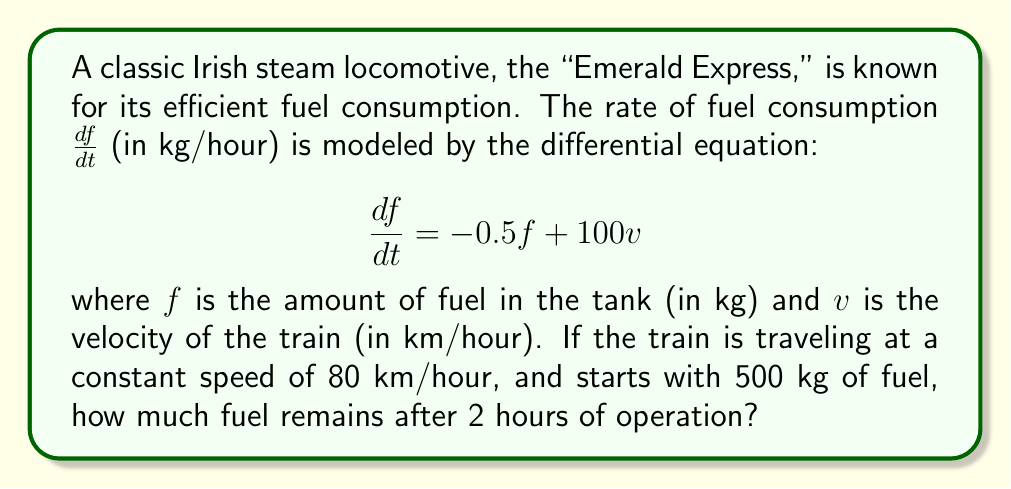Solve this math problem. To solve this problem, we need to follow these steps:

1) First, we substitute the given velocity into the differential equation:
   $$\frac{df}{dt} = -0.5f + 100(80) = -0.5f + 8000$$

2) This is a first-order linear differential equation of the form:
   $$\frac{df}{dt} + 0.5f = 8000$$

3) The general solution to this type of equation is:
   $$f(t) = Ce^{-0.5t} + 16000$$
   where $C$ is a constant we need to determine.

4) We use the initial condition: at $t=0$, $f(0) = 500$:
   $$500 = C + 16000$$
   $$C = -15500$$

5) So, our particular solution is:
   $$f(t) = -15500e^{-0.5t} + 16000$$

6) To find the fuel remaining after 2 hours, we evaluate $f(2)$:
   $$f(2) = -15500e^{-0.5(2)} + 16000$$
   $$= -15500e^{-1} + 16000$$
   $$\approx -5702.76 + 16000$$
   $$\approx 10297.24$$

Therefore, after 2 hours of operation, approximately 10,297.24 kg of fuel remains in the tank.
Answer: Approximately 10,297.24 kg of fuel remains after 2 hours. 